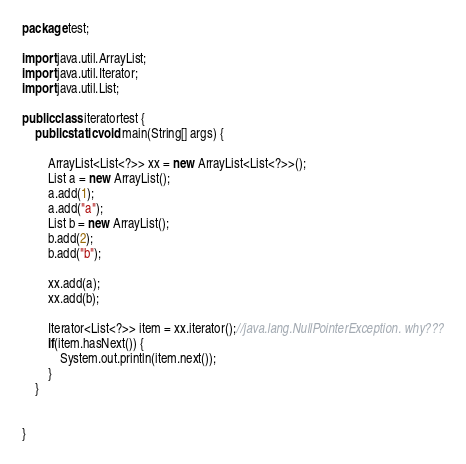Convert code to text. <code><loc_0><loc_0><loc_500><loc_500><_Java_>package test;

import java.util.ArrayList;
import java.util.Iterator;
import java.util.List;

public class iteratortest {
	public static void main(String[] args) {
	    
		ArrayList<List<?>> xx = new ArrayList<List<?>>();
		List a = new ArrayList();
		a.add(1);
		a.add("a");
		List b = new ArrayList();
		b.add(2);
		b.add("b");
		
		xx.add(a);
		xx.add(b);

		Iterator<List<?>> item = xx.iterator();//java.lang.NullPointerException. why???
		if(item.hasNext()) {
			System.out.println(item.next());
		}
	}


}
</code> 